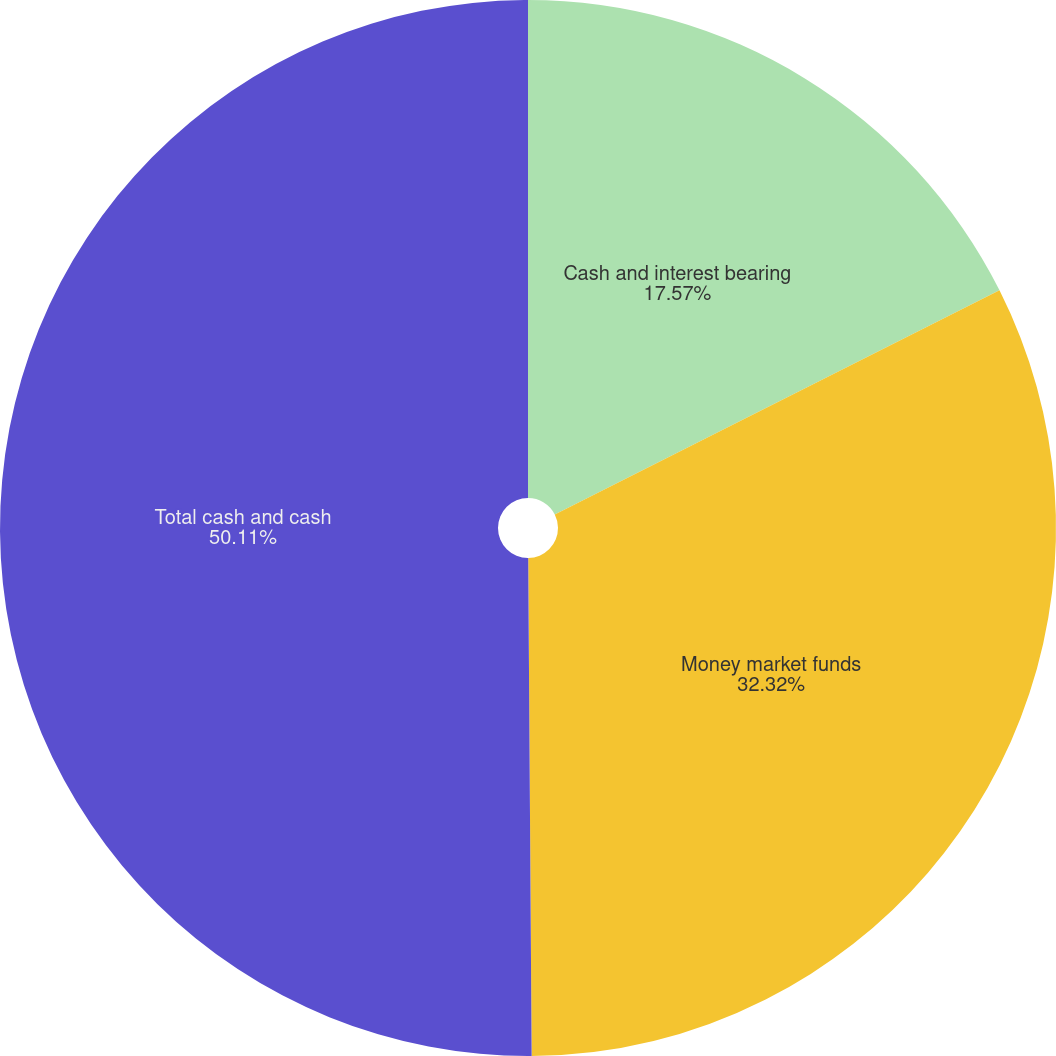<chart> <loc_0><loc_0><loc_500><loc_500><pie_chart><fcel>Cash and interest bearing<fcel>Money market funds<fcel>Total cash and cash<nl><fcel>17.57%<fcel>32.32%<fcel>50.11%<nl></chart> 